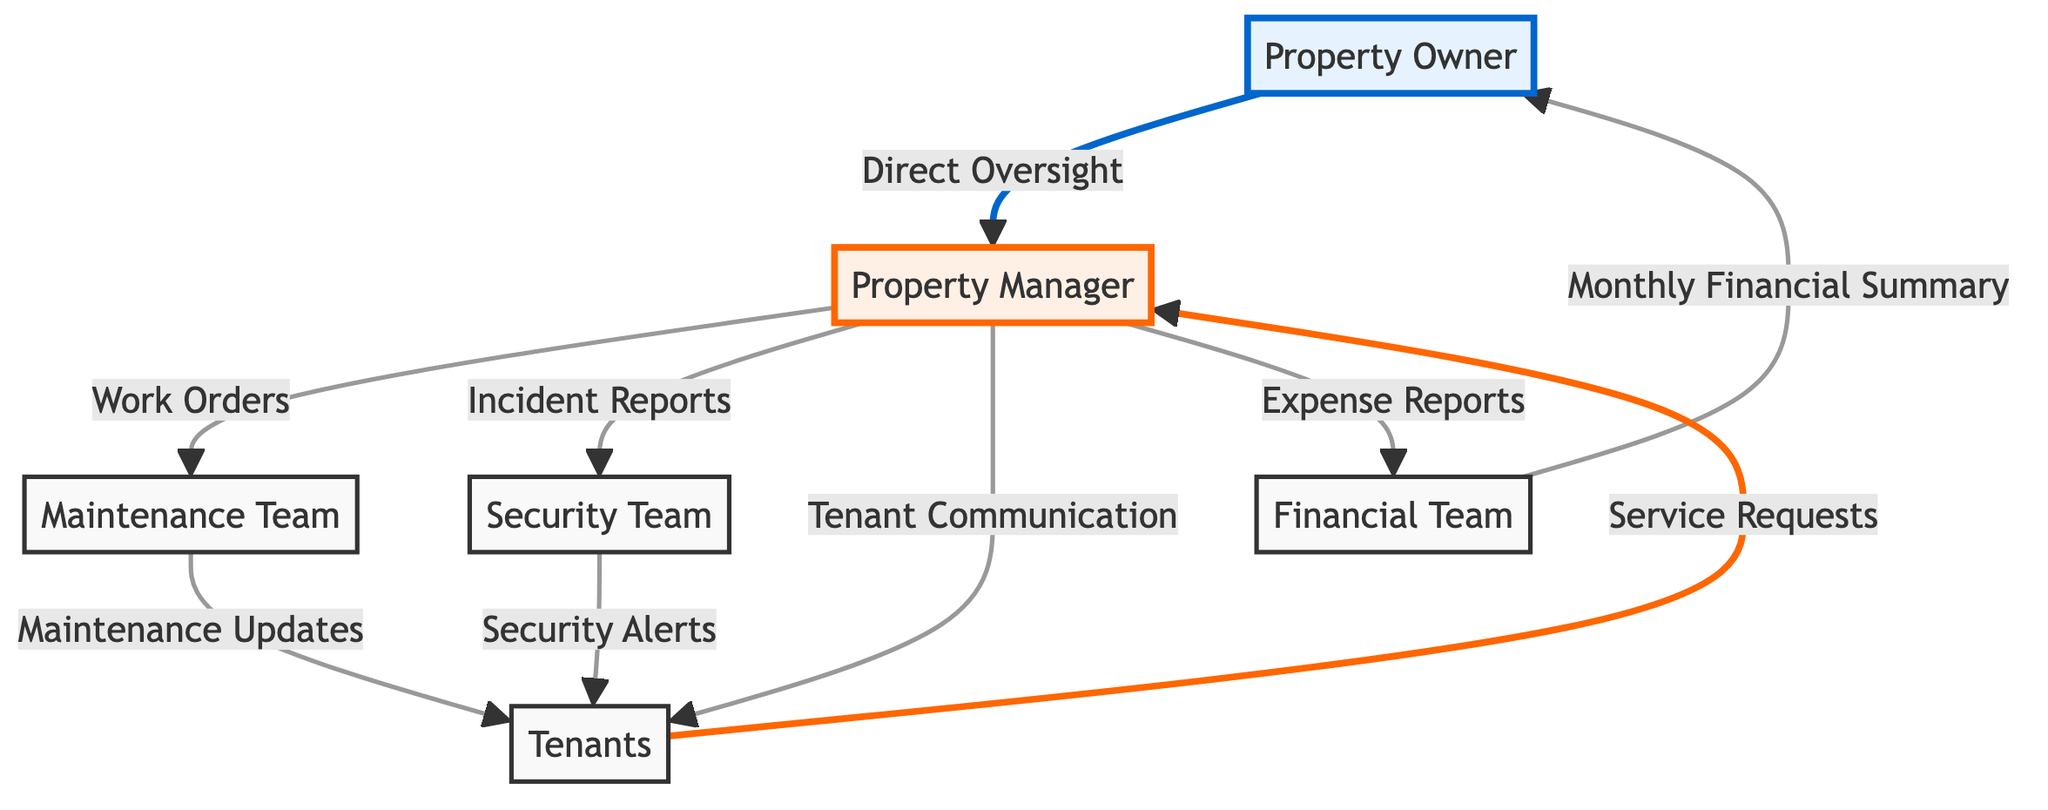What's the total number of nodes in the diagram? The nodes in the diagram represent different entities involved in property management. By counting each distinct entity listed under "nodes," we find six entities: Property Owner, Property Manager, Maintenance Team, Security Team, Tenants, and Financial Team. Thus, the total number of nodes is 6.
Answer: 6 How are the Property Owner and Property Manager connected? The connection between the Property Owner and Property Manager is indicated by the edge between them with the label "Direct Oversight." This shows that the Property Owner directly oversees the Property Manager's activities.
Answer: Direct Oversight What type of communication is established from the Property Manager to the Tenants? The communication from the Property Manager to the Tenants is denoted by the edge labeled "Tenant Communication." This implies that the Property Manager is responsible for communicating directly with the Tenants regarding various matters.
Answer: Tenant Communication Which team receives Service Requests from the Tenants? According to the diagram, the Tenants send Service Requests directly to the Property Manager, making the Property Manager the team that receives these requests.
Answer: Property Manager What is the relationship between the Financial Team and the Property Owner? The relationship is represented by the edge labeled "Monthly Financial Summary," indicating that the Financial Team provides a summary of financial activities to the Property Owner on a monthly basis.
Answer: Monthly Financial Summary How many edges are there in the diagram? To find the total number of edges, we can count the connections made between the entities in the "edges" section. There are nine distinct connections, leading to a total of 9 edges in the diagram.
Answer: 9 Which team provides Maintenance Updates to the Tenants? The Maintenance Updates are provided by the Maintenance Team, as indicated by the edge labeled "Maintenance Updates" coming from the Maintenance Team to the Tenants.
Answer: Maintenance Team What prompt does the Security Team receive from the Property Manager? The edge labeled "Incident Reports" shows that the Security Team receives reports regarding incidents from the Property Manager, facilitating communication related to security issues.
Answer: Incident Reports Which entity communicates Security Alerts to the Tenants? The Security Team is responsible for sending Security Alerts to the Tenants, as shown by the edge labeled "Security Alerts" that connects these two entities.
Answer: Security Team 